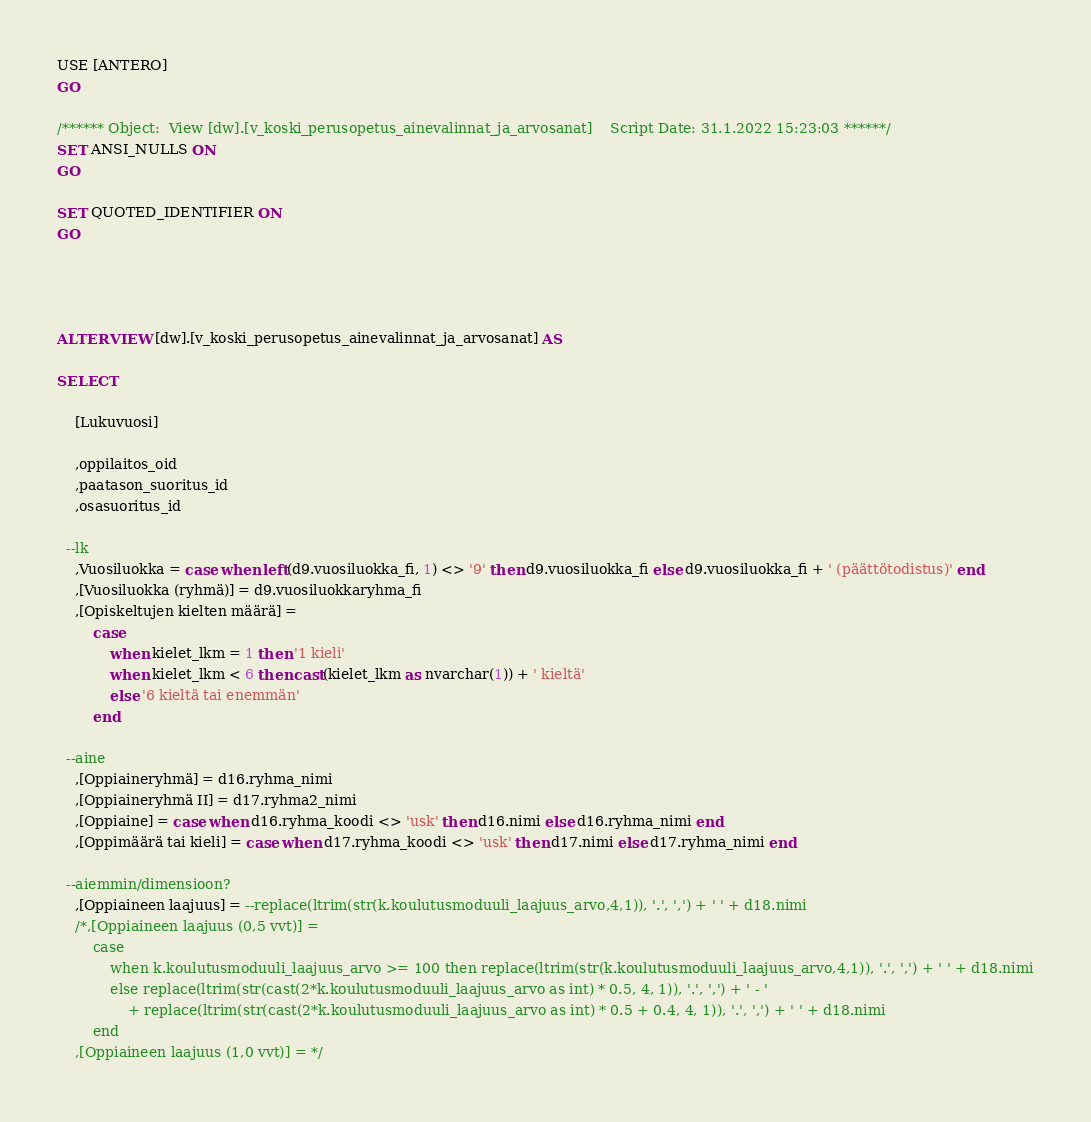Convert code to text. <code><loc_0><loc_0><loc_500><loc_500><_SQL_>USE [ANTERO]
GO

/****** Object:  View [dw].[v_koski_perusopetus_ainevalinnat_ja_arvosanat]    Script Date: 31.1.2022 15:23:03 ******/
SET ANSI_NULLS ON
GO

SET QUOTED_IDENTIFIER ON
GO




ALTER VIEW [dw].[v_koski_perusopetus_ainevalinnat_ja_arvosanat] AS

SELECT 

	[Lukuvuosi]

	,oppilaitos_oid
	,paatason_suoritus_id
	,osasuoritus_id

  --lk
	,Vuosiluokka = case when left(d9.vuosiluokka_fi, 1) <> '9' then d9.vuosiluokka_fi else d9.vuosiluokka_fi + ' (päättötodistus)' end
	,[Vuosiluokka (ryhmä)] = d9.vuosiluokkaryhma_fi
	,[Opiskeltujen kielten määrä] = 
		case 
			when kielet_lkm = 1 then '1 kieli' 
			when kielet_lkm < 6 then cast(kielet_lkm as nvarchar(1)) + ' kieltä' 
			else '6 kieltä tai enemmän'
		end

  --aine
	,[Oppiaineryhmä] = d16.ryhma_nimi
	,[Oppiaineryhmä II] = d17.ryhma2_nimi 
    ,[Oppiaine] = case when d16.ryhma_koodi <> 'usk' then d16.nimi else d16.ryhma_nimi end
	,[Oppimäärä tai kieli] = case when d17.ryhma_koodi <> 'usk' then d17.nimi else d17.ryhma_nimi end

  --aiemmin/dimensioon?
    ,[Oppiaineen laajuus] = --replace(ltrim(str(k.koulutusmoduuli_laajuus_arvo,4,1)), '.', ',') + ' ' + d18.nimi
	/*,[Oppiaineen laajuus (0,5 vvt)] = 
		case 
			when k.koulutusmoduuli_laajuus_arvo >= 100 then replace(ltrim(str(k.koulutusmoduuli_laajuus_arvo,4,1)), '.', ',') + ' ' + d18.nimi
			else replace(ltrim(str(cast(2*k.koulutusmoduuli_laajuus_arvo as int) * 0.5, 4, 1)), '.', ',') + ' - ' 
				+ replace(ltrim(str(cast(2*k.koulutusmoduuli_laajuus_arvo as int) * 0.5 + 0.4, 4, 1)), '.', ',') + ' ' + d18.nimi
		end
	,[Oppiaineen laajuus (1,0 vvt)] = */</code> 